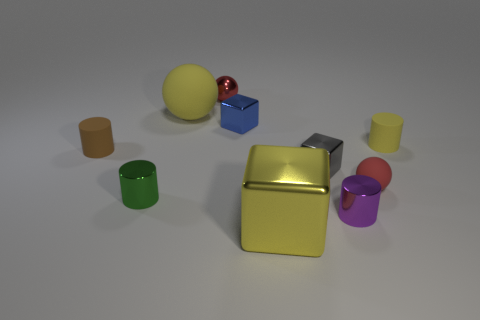There is a large yellow object that is behind the red sphere that is on the right side of the red shiny object; what is its shape?
Your response must be concise. Sphere. There is a tiny ball that is on the left side of the tiny gray shiny thing; does it have the same color as the big rubber sphere?
Offer a terse response. No. There is a small thing that is in front of the brown cylinder and left of the big block; what is its color?
Offer a terse response. Green. Is there a cylinder made of the same material as the green object?
Your answer should be compact. Yes. The gray shiny object is what size?
Your answer should be compact. Small. There is a red object that is in front of the tiny ball behind the tiny blue metallic object; what size is it?
Make the answer very short. Small. There is a yellow object that is the same shape as the purple metallic thing; what is its material?
Make the answer very short. Rubber. What number of big yellow metal blocks are there?
Offer a terse response. 1. There is a metallic cylinder that is in front of the green thing in front of the red thing that is behind the brown cylinder; what color is it?
Your response must be concise. Purple. Are there fewer tiny gray shiny cubes than things?
Offer a very short reply. Yes. 